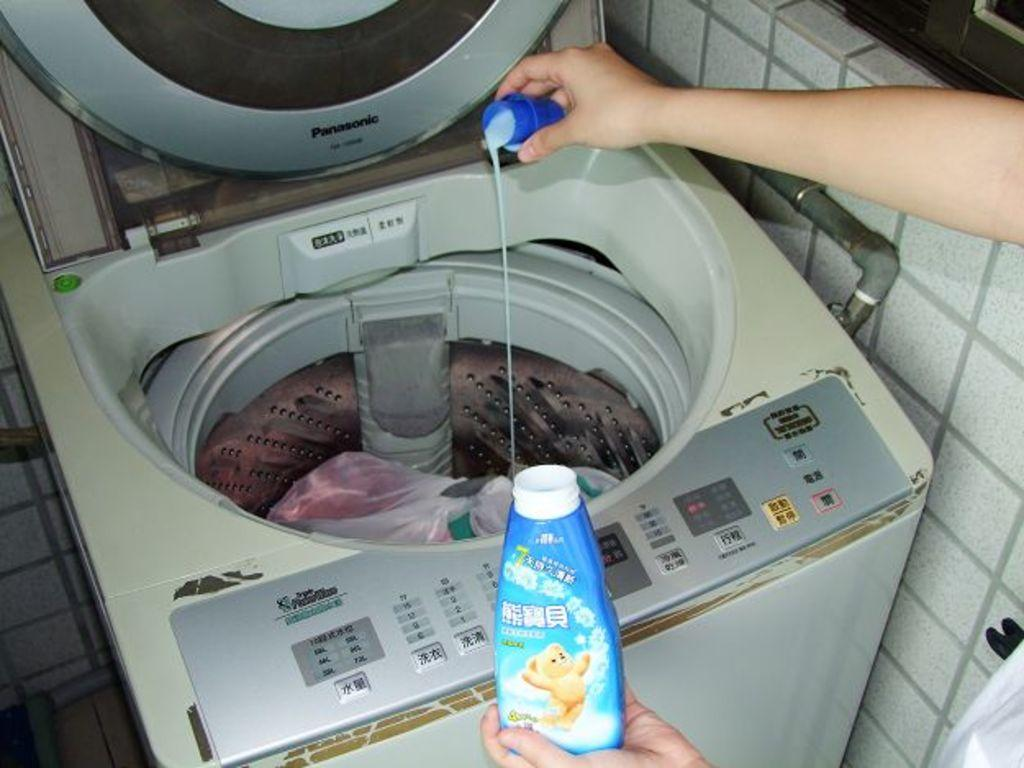What appliance can be seen in the image? There is a washing machine in the image. What is the person's hand holding in the image? The person's hand is holding a bottle and a cap in the image. What type of structure is visible in the image? There is a wall visible in the image. What type of locket is the laborer wearing in the image? There is no laborer or locket present in the image. What type of sheet is covering the washing machine in the image? There is no sheet covering the washing machine in the image. 